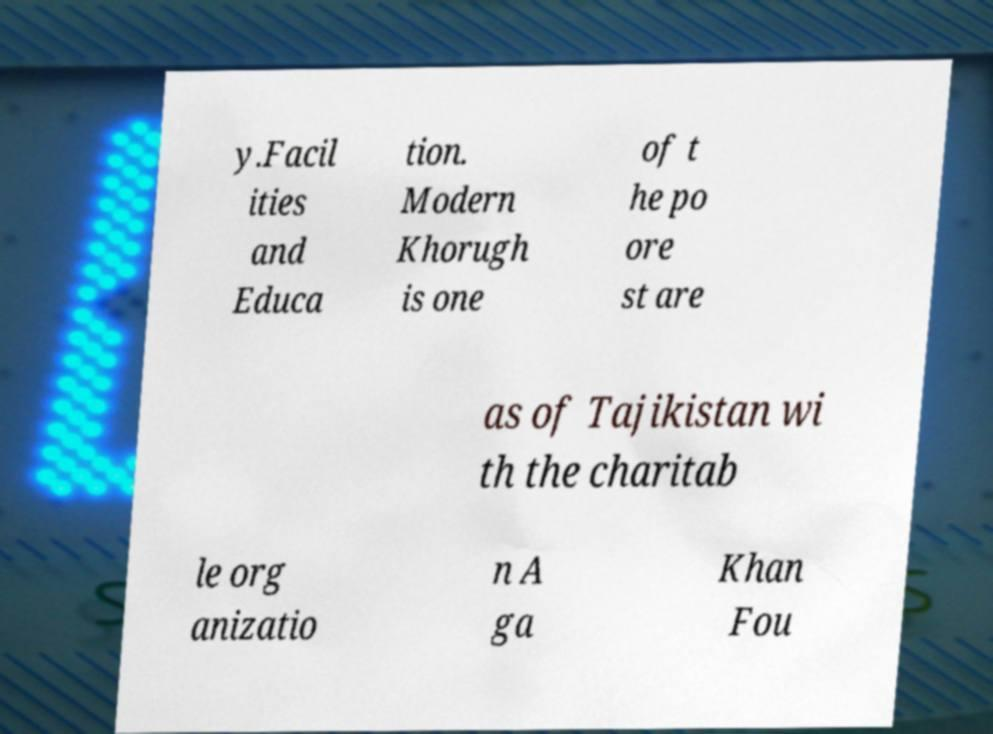For documentation purposes, I need the text within this image transcribed. Could you provide that? y.Facil ities and Educa tion. Modern Khorugh is one of t he po ore st are as of Tajikistan wi th the charitab le org anizatio n A ga Khan Fou 